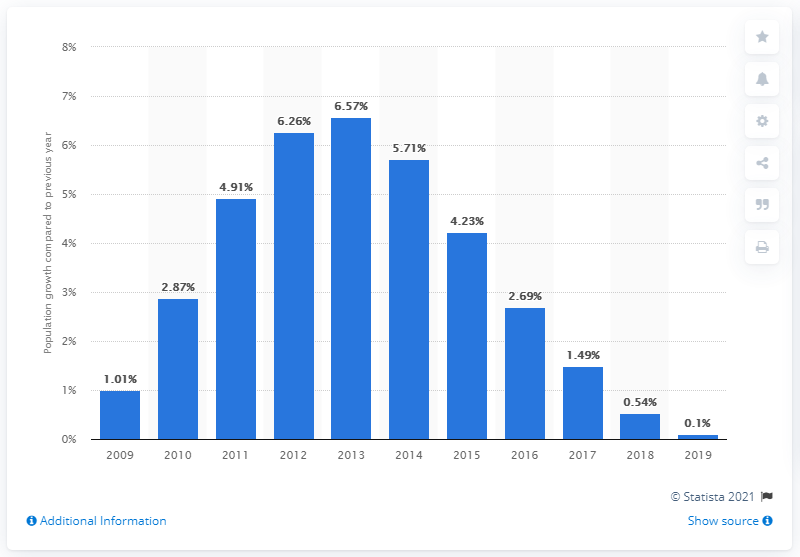List a handful of essential elements in this visual. The population of Lebanon increased by 0.1% in 2019. 